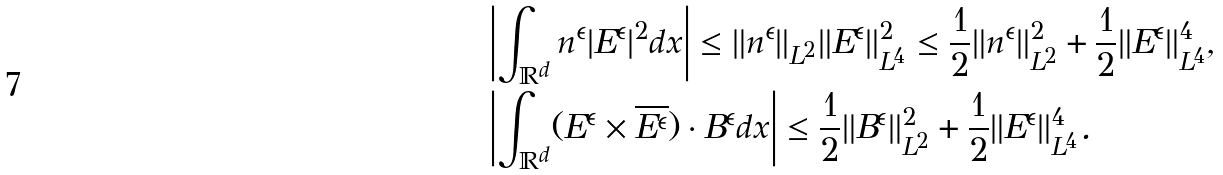<formula> <loc_0><loc_0><loc_500><loc_500>& \left | \int _ { \mathbb { R } ^ { d } } n ^ { \epsilon } | E ^ { \epsilon } | ^ { 2 } d x \right | \leq \| n ^ { \epsilon } \| _ { L ^ { 2 } } \| E ^ { \epsilon } \| _ { L ^ { 4 } } ^ { 2 } \leq \frac { 1 } { 2 } \| n ^ { \epsilon } \| _ { L ^ { 2 } } ^ { 2 } + \frac { 1 } { 2 } \| E ^ { \epsilon } \| _ { L ^ { 4 } } ^ { 4 } , \\ & \left | \int _ { \mathbb { R } ^ { d } } ( E ^ { \epsilon } \times \overline { E ^ { \epsilon } } ) \cdot B ^ { \epsilon } d x \right | \leq \frac { 1 } { 2 } \| B ^ { \epsilon } \| _ { L ^ { 2 } } ^ { 2 } + \frac { 1 } { 2 } \| E ^ { \epsilon } \| _ { L ^ { 4 } } ^ { 4 } .</formula> 